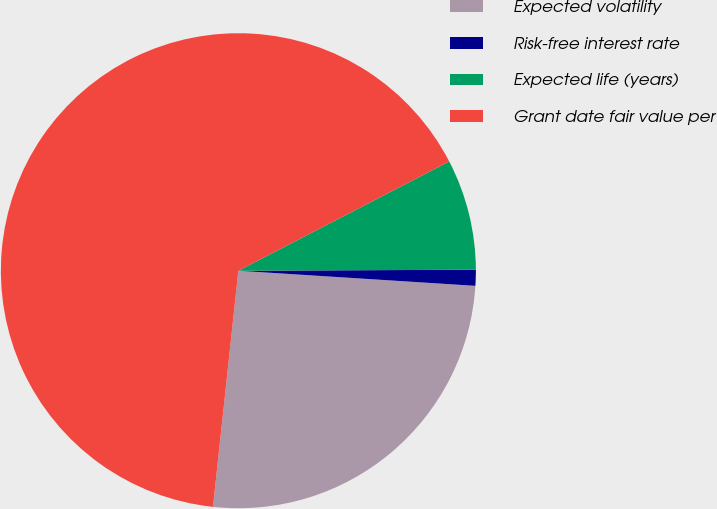Convert chart. <chart><loc_0><loc_0><loc_500><loc_500><pie_chart><fcel>Expected volatility<fcel>Risk-free interest rate<fcel>Expected life (years)<fcel>Grant date fair value per<nl><fcel>25.69%<fcel>1.08%<fcel>7.54%<fcel>65.68%<nl></chart> 